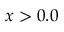<formula> <loc_0><loc_0><loc_500><loc_500>x > 0 . 0</formula> 